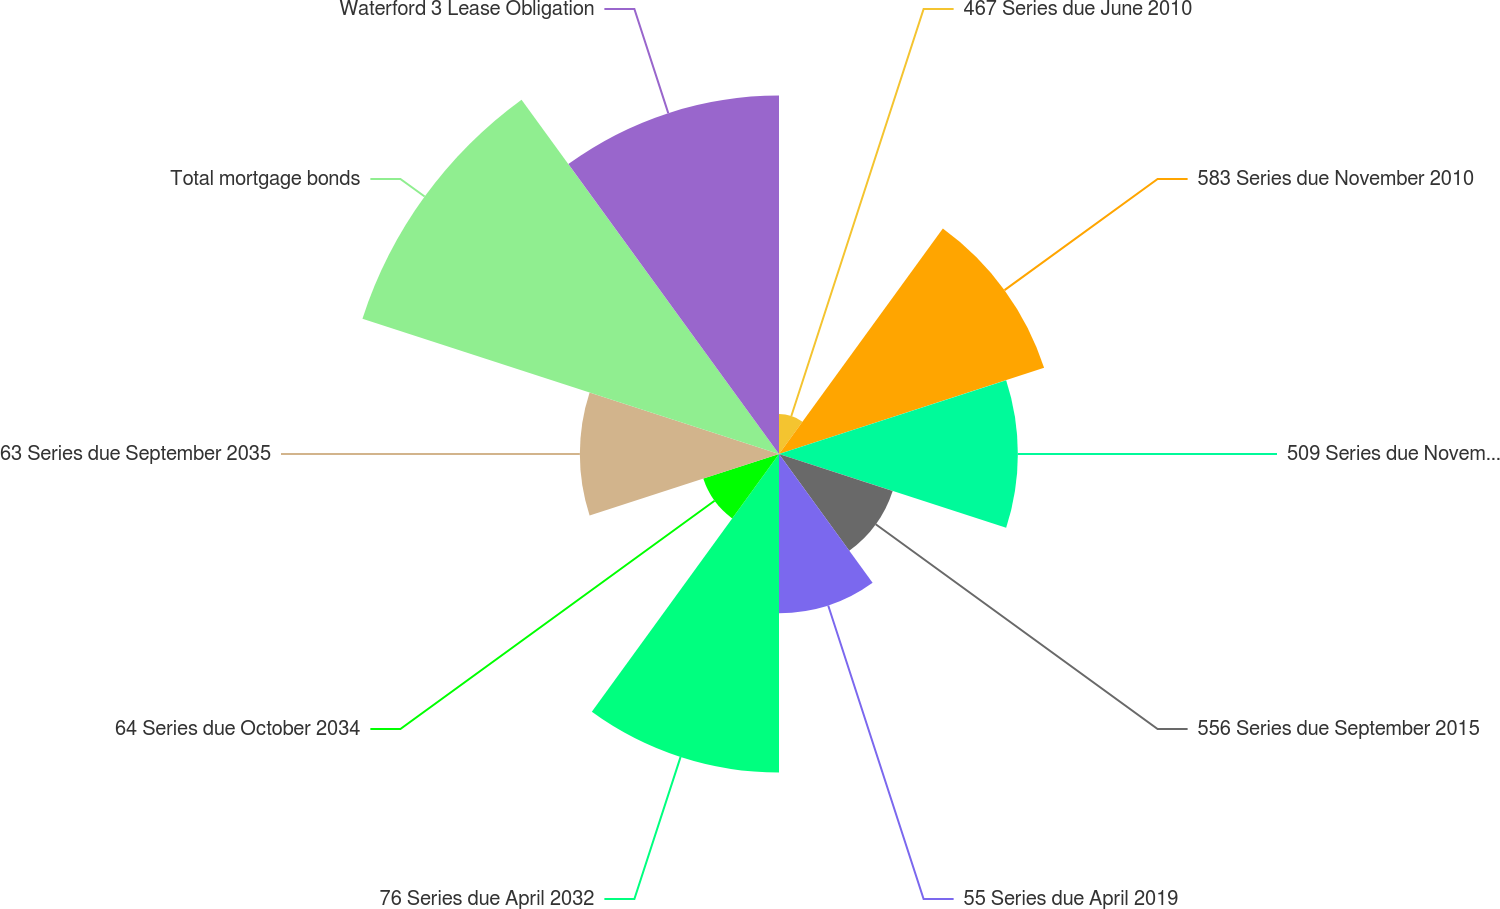<chart> <loc_0><loc_0><loc_500><loc_500><pie_chart><fcel>467 Series due June 2010<fcel>583 Series due November 2010<fcel>509 Series due November 2014<fcel>556 Series due September 2015<fcel>55 Series due April 2019<fcel>76 Series due April 2032<fcel>64 Series due October 2034<fcel>63 Series due September 2035<fcel>Total mortgage bonds<fcel>Waterford 3 Lease Obligation<nl><fcel>1.79%<fcel>12.5%<fcel>10.71%<fcel>5.36%<fcel>7.14%<fcel>14.28%<fcel>3.57%<fcel>8.93%<fcel>19.64%<fcel>16.07%<nl></chart> 